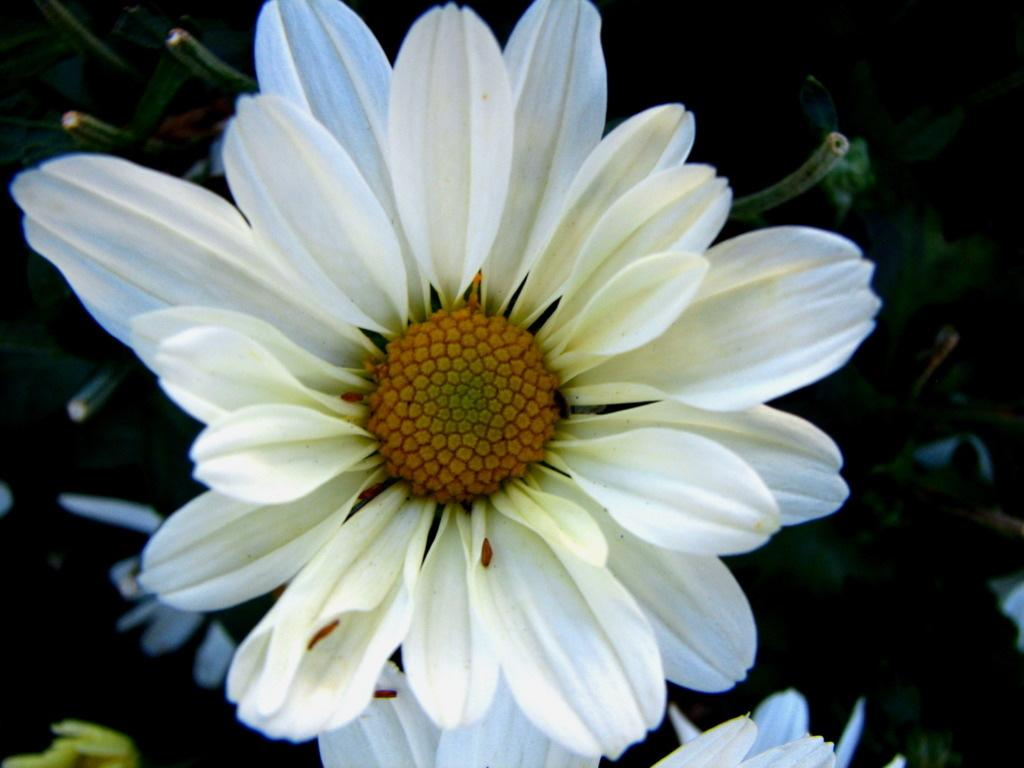What is the color of the sunflower in the image? The sunflower in the image is white. What other elements can be seen in the image besides the sunflower? There are green color leaves in the image. Who is the owner of the marble in the image? There is no marble present in the image. What is the relationship between the sunflower and the brother in the image? There is no brother mentioned or depicted in the image. 